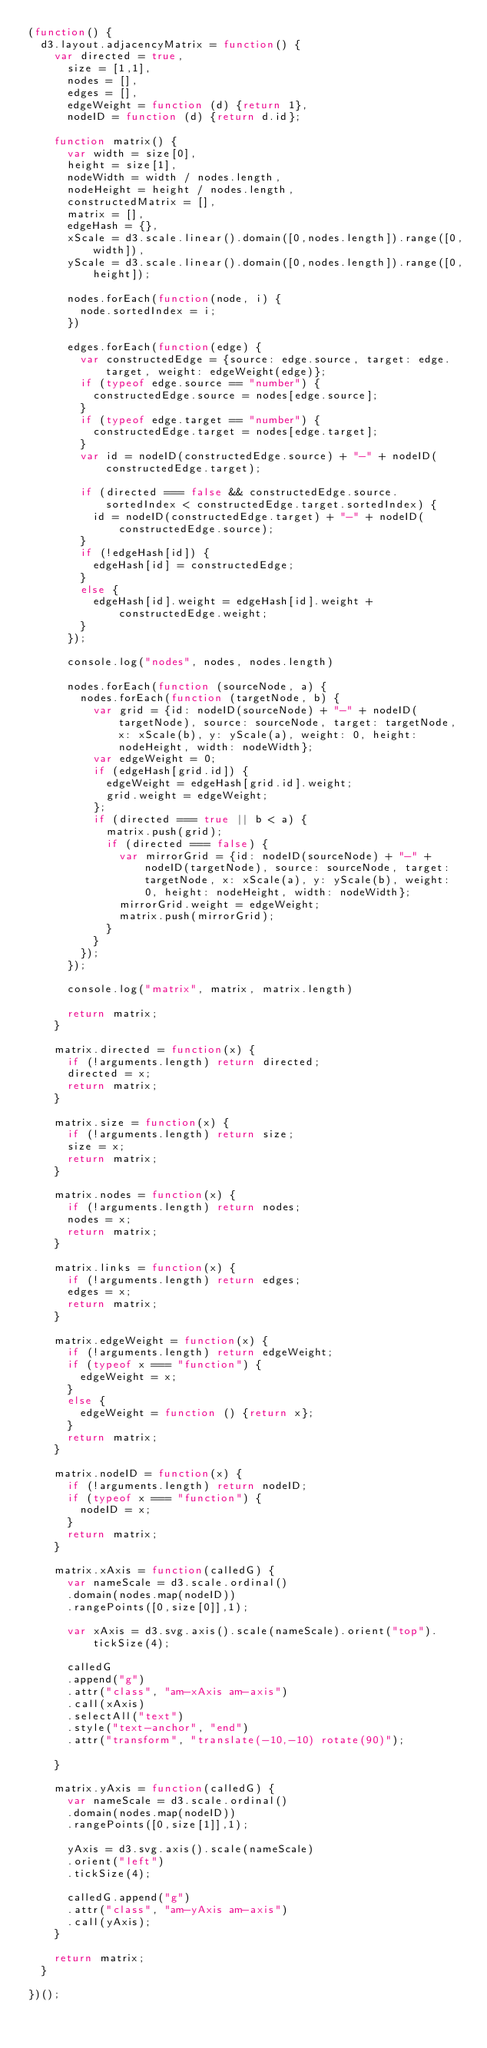<code> <loc_0><loc_0><loc_500><loc_500><_JavaScript_>(function() {
  d3.layout.adjacencyMatrix = function() {
    var directed = true,
      size = [1,1],
      nodes = [],
      edges = [],
      edgeWeight = function (d) {return 1},
      nodeID = function (d) {return d.id};

    function matrix() {
      var width = size[0],
      height = size[1],
      nodeWidth = width / nodes.length,
      nodeHeight = height / nodes.length,
      constructedMatrix = [],
      matrix = [],
      edgeHash = {},
      xScale = d3.scale.linear().domain([0,nodes.length]).range([0,width]),
      yScale = d3.scale.linear().domain([0,nodes.length]).range([0,height]);

      nodes.forEach(function(node, i) {
        node.sortedIndex = i;
      })

      edges.forEach(function(edge) {
        var constructedEdge = {source: edge.source, target: edge.target, weight: edgeWeight(edge)};
        if (typeof edge.source == "number") {
          constructedEdge.source = nodes[edge.source];
        }
        if (typeof edge.target == "number") {
          constructedEdge.target = nodes[edge.target];
        }
        var id = nodeID(constructedEdge.source) + "-" + nodeID(constructedEdge.target);

        if (directed === false && constructedEdge.source.sortedIndex < constructedEdge.target.sortedIndex) {
          id = nodeID(constructedEdge.target) + "-" + nodeID(constructedEdge.source);
        }
        if (!edgeHash[id]) {
          edgeHash[id] = constructedEdge;
        }
        else {
          edgeHash[id].weight = edgeHash[id].weight + constructedEdge.weight;
        }
      });

      console.log("nodes", nodes, nodes.length)

      nodes.forEach(function (sourceNode, a) {
        nodes.forEach(function (targetNode, b) {
          var grid = {id: nodeID(sourceNode) + "-" + nodeID(targetNode), source: sourceNode, target: targetNode, x: xScale(b), y: yScale(a), weight: 0, height: nodeHeight, width: nodeWidth};
          var edgeWeight = 0;
          if (edgeHash[grid.id]) {
            edgeWeight = edgeHash[grid.id].weight;
            grid.weight = edgeWeight;
          };
          if (directed === true || b < a) {
            matrix.push(grid);
            if (directed === false) {
              var mirrorGrid = {id: nodeID(sourceNode) + "-" + nodeID(targetNode), source: sourceNode, target: targetNode, x: xScale(a), y: yScale(b), weight: 0, height: nodeHeight, width: nodeWidth};
              mirrorGrid.weight = edgeWeight;
              matrix.push(mirrorGrid);
            }
          }
        });
      });

      console.log("matrix", matrix, matrix.length)

      return matrix;
    }

    matrix.directed = function(x) {
      if (!arguments.length) return directed;
      directed = x;
      return matrix;
    }

    matrix.size = function(x) {
      if (!arguments.length) return size;
      size = x;
      return matrix;
    }

    matrix.nodes = function(x) {
      if (!arguments.length) return nodes;
      nodes = x;
      return matrix;
    }

    matrix.links = function(x) {
      if (!arguments.length) return edges;
      edges = x;
      return matrix;
    }

    matrix.edgeWeight = function(x) {
      if (!arguments.length) return edgeWeight;
      if (typeof x === "function") {
        edgeWeight = x;
      }
      else {
        edgeWeight = function () {return x};
      }
      return matrix;
    }

    matrix.nodeID = function(x) {
      if (!arguments.length) return nodeID;
      if (typeof x === "function") {
        nodeID = x;
      }
      return matrix;
    }

    matrix.xAxis = function(calledG) {
      var nameScale = d3.scale.ordinal()
      .domain(nodes.map(nodeID))
      .rangePoints([0,size[0]],1);

      var xAxis = d3.svg.axis().scale(nameScale).orient("top").tickSize(4);

      calledG
      .append("g")
      .attr("class", "am-xAxis am-axis")
      .call(xAxis)
      .selectAll("text")
      .style("text-anchor", "end")
      .attr("transform", "translate(-10,-10) rotate(90)");

    }

    matrix.yAxis = function(calledG) {
      var nameScale = d3.scale.ordinal()
      .domain(nodes.map(nodeID))
      .rangePoints([0,size[1]],1);

      yAxis = d3.svg.axis().scale(nameScale)
      .orient("left")
      .tickSize(4);

      calledG.append("g")
      .attr("class", "am-yAxis am-axis")
      .call(yAxis);
    }

    return matrix;
  }

})();</code> 